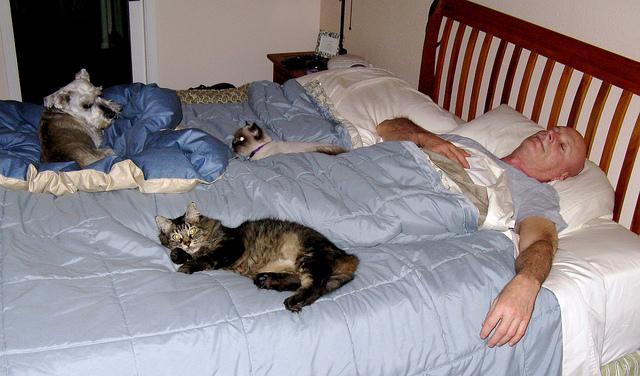How many species rest here?

Choices:
A) three
B) none
C) one
D) ten three 